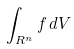<formula> <loc_0><loc_0><loc_500><loc_500>\int _ { R ^ { n } } f \, d V</formula> 